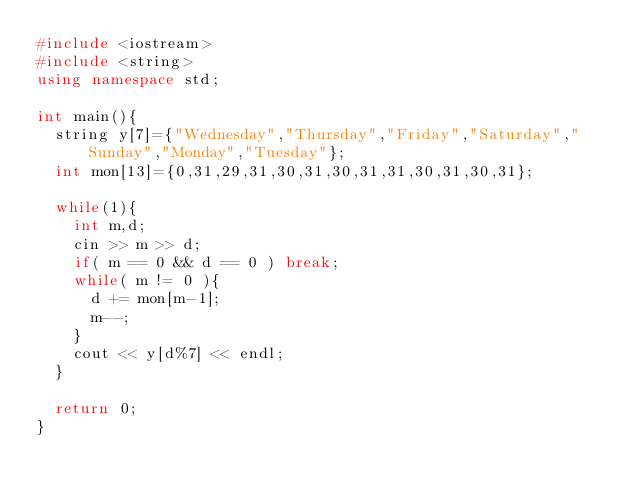<code> <loc_0><loc_0><loc_500><loc_500><_C++_>#include <iostream>
#include <string>
using namespace std;
 
int main(){
  string y[7]={"Wednesday","Thursday","Friday","Saturday","Sunday","Monday","Tuesday"};
  int mon[13]={0,31,29,31,30,31,30,31,31,30,31,30,31};
 
  while(1){
    int m,d;
    cin >> m >> d;
    if( m == 0 && d == 0 ) break;
    while( m != 0 ){
      d += mon[m-1];
      m--;
    }
    cout << y[d%7] << endl;
  }
 
  return 0;
}</code> 